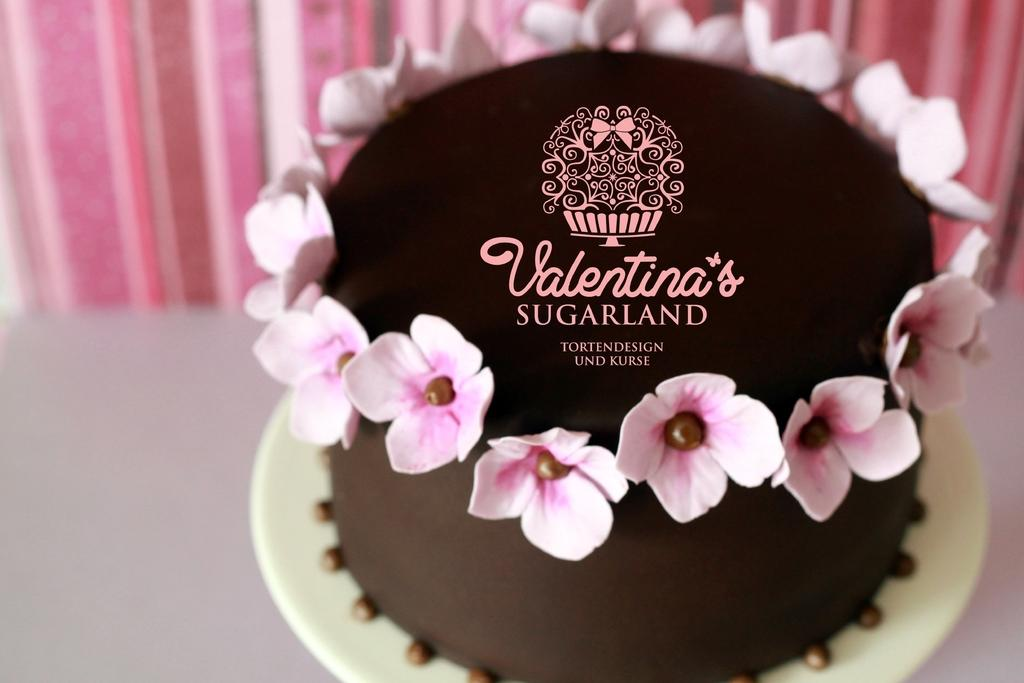What type of cake is shown in the image? There is a brown color cake in the image. How is the cake decorated? The cake is decorated with pink flowers. What can be seen in the background of the image? There is a curtain in the background of the image. Where is the kitty sleeping in the image? There is no kitty present in the image. What type of mailbox is visible in the image? There is no mailbox present in the image. 